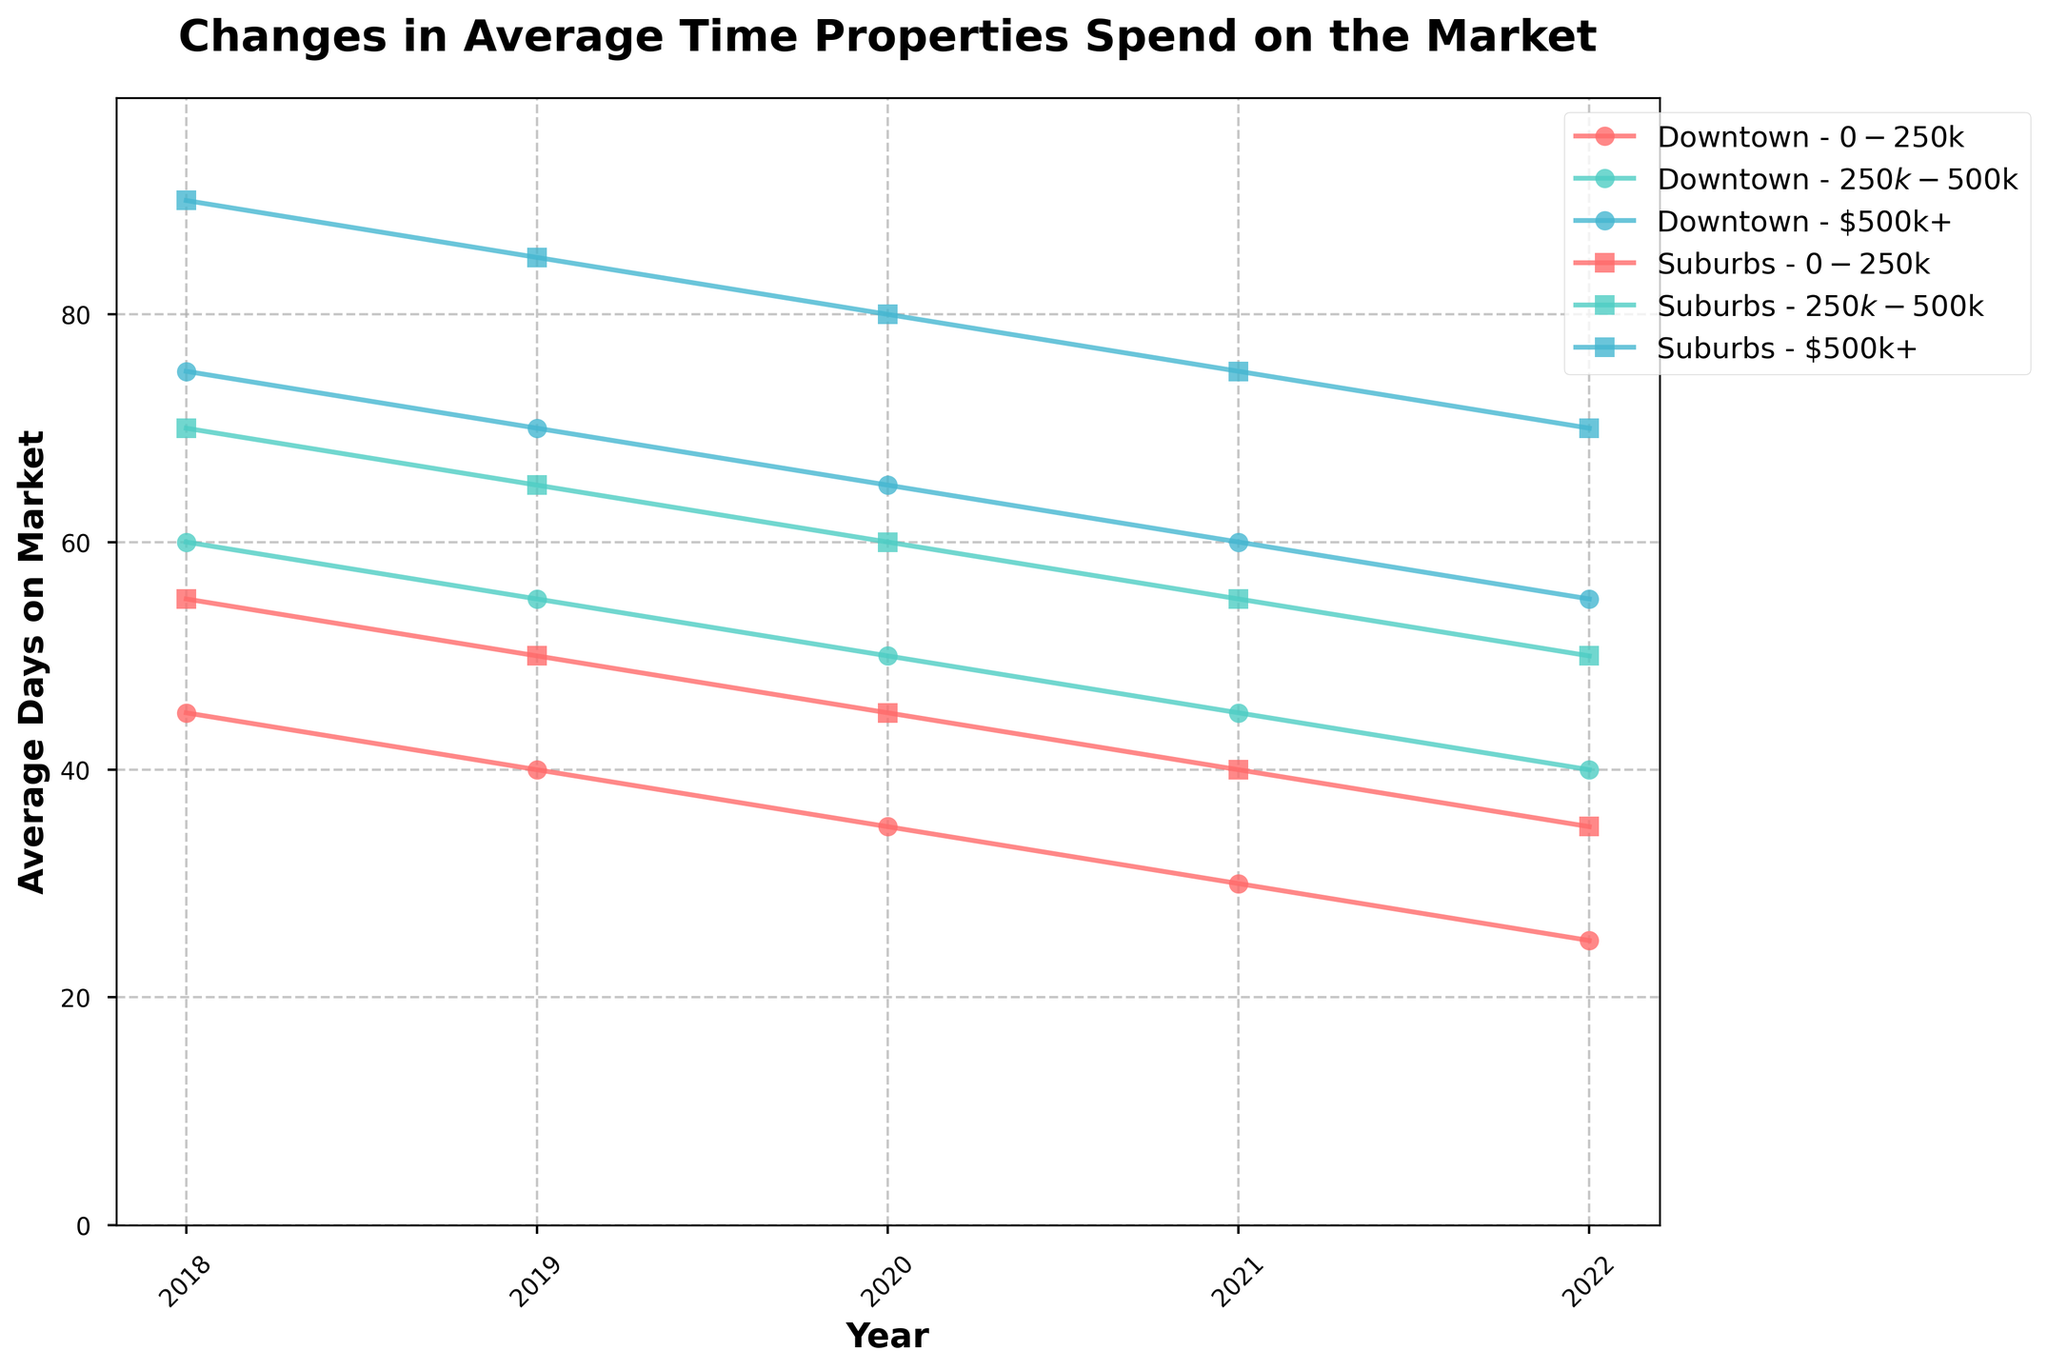What is the trend for the average days properties spend on the market for Downtown properties priced between $250k-$500k from 2018 to 2022? To identify the trend, look at the plotted line for "Downtown - $250k-$500k" from 2018 to 2022. Notice whether it is generally ascending, descending, or remains stable. For this segment, the average days on market decreases from 60 days in 2018 to 40 days in 2022.
Answer: Decreasing Which location and price range experienced the least time on the market in 2022? Locate the data points corresponding to the year 2022 and find the one with the smallest value for average days on market. The "Downtown - $0-$250k" line shows 25 days on the market, which is the smallest value in 2022.
Answer: Downtown - $0-$250k Between 2018 and 2022, has the average time properties spend on the market for Suburbs properties priced at $500k+ decreased or increased, and by how much? Compare the value in 2018 with the value in 2022 for "Suburbs - $500k+." In 2018, it's 90 days, and in 2022, it's 70 days. The difference is 90 - 70 = 20 days, showing a decrease.
Answer: Decreased by 20 days Which price range has shown a more significant reduction in average days on market in Downtown from 2018 to 2022: $0-$250k or $500k+? Calculate the differences for both ranges: for $0-$250k, it's 45 in 2018 and 25 in 2022, a reduction of 20 days; for $500k+, it's 75 in 2018 and 55 in 2022, a reduction of 20 days. Both ranges show an equal reduction.
Answer: Tie (20 days each) Comparing 2018 and 2022, which location and price range combination has exhibited the most significant improvement (greatest decrease) in reducing the average days on market? Calculate the difference for each combination between 2018 and 2022, then identify the largest reduction. For example, "Downtown - $500k+" dropped from 75 to 55 (20 days), but "Downtown - $0-$250k" dropped from 45 to 25 (20 days), so on till all combinations are checked. The largest decrease is 20 days, shown by multiple combinations.
Answer: Downtown - $0-$250k ($250k-$500k and $500k+ also) Is it true that higher priced properties ($500k+) in Suburbs took more time to sell compared to Downtown in each year from 2018 to 2022? Analyze the plotted lines for $500k+ in both Suburbs and Downtown for each year. In each case, Suburbs (consistently above with values 90, 85, 80, 75, and 70) always have higher values than Downtown (75, 70, 65, 60, 55).
Answer: True For which location did properties priced $250k-$500k consistently spend fewer days on the market from 2018 to 2022? Compare the "Downtown - $250k-$500k" and "Suburbs - $250k-$500k" lines over the period. Downtown consistently has lower values (60, 55, 50, 45, 40) compared to Suburbs (70, 65, 60, 55, 50).
Answer: Downtown During which year did the gap in average days on the market between $0-$250k Downtown and Suburbs properties reach its maximum? Calculate the difference for each year between Downtown and Suburbs in the $0-$250k range. The largest difference occurs when the values for Downtown (25) and Suburbs (35) are most apart, which is 10 days and happens in 2022.
Answer: 2022 